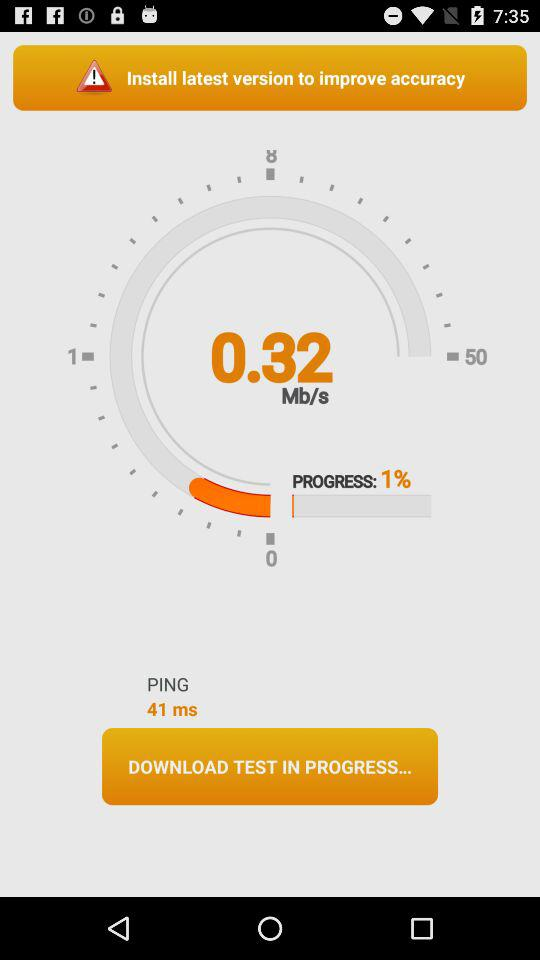What is the percentage of the download that has been completed?
Answer the question using a single word or phrase. 1% 